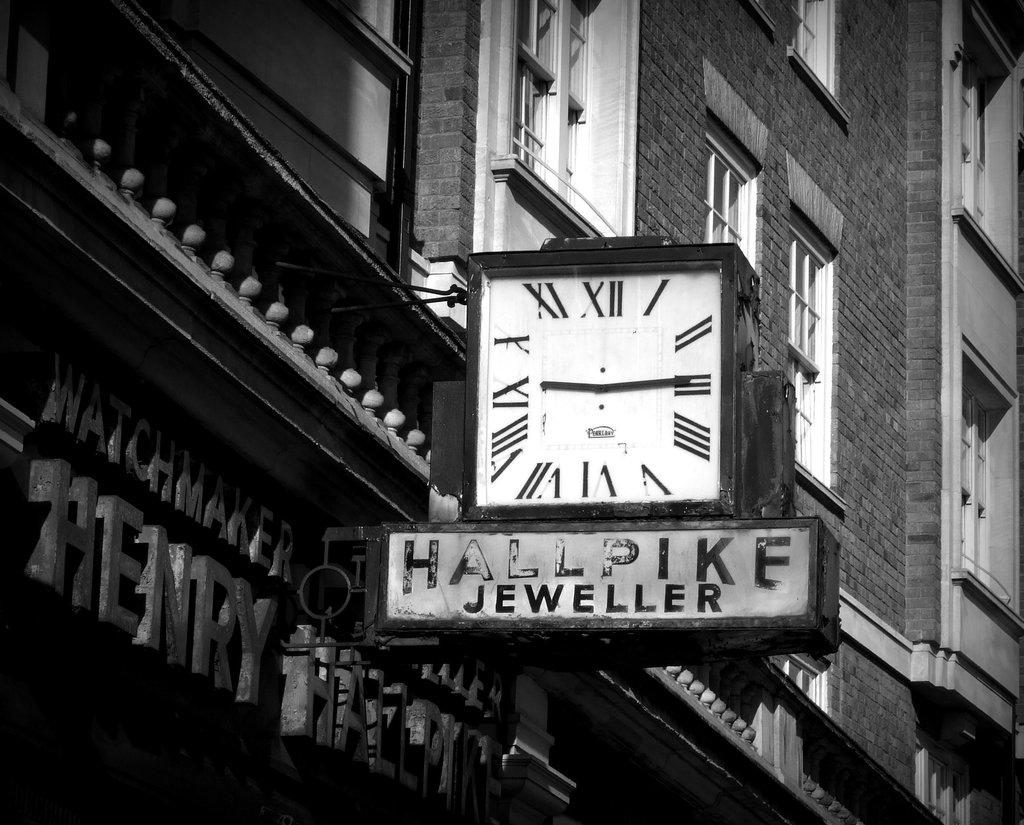<image>
Create a compact narrative representing the image presented. A clock above a sign that says Hall Pike Jeweller. 